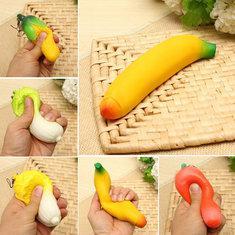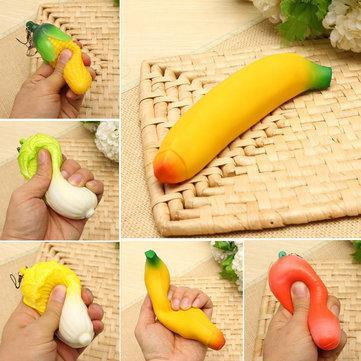The first image is the image on the left, the second image is the image on the right. For the images displayed, is the sentence "Only fake bananas shown." factually correct? Answer yes or no. Yes. The first image is the image on the left, the second image is the image on the right. For the images shown, is this caption "Someone is placing a banana in a banana slicer in at least one of the pictures." true? Answer yes or no. No. 